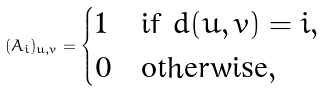<formula> <loc_0><loc_0><loc_500><loc_500>( A _ { i } ) _ { u , v } = \begin{cases} 1 & \text {if $d(u,v)=i$} , \\ 0 & \text {otherwise} , \end{cases}</formula> 